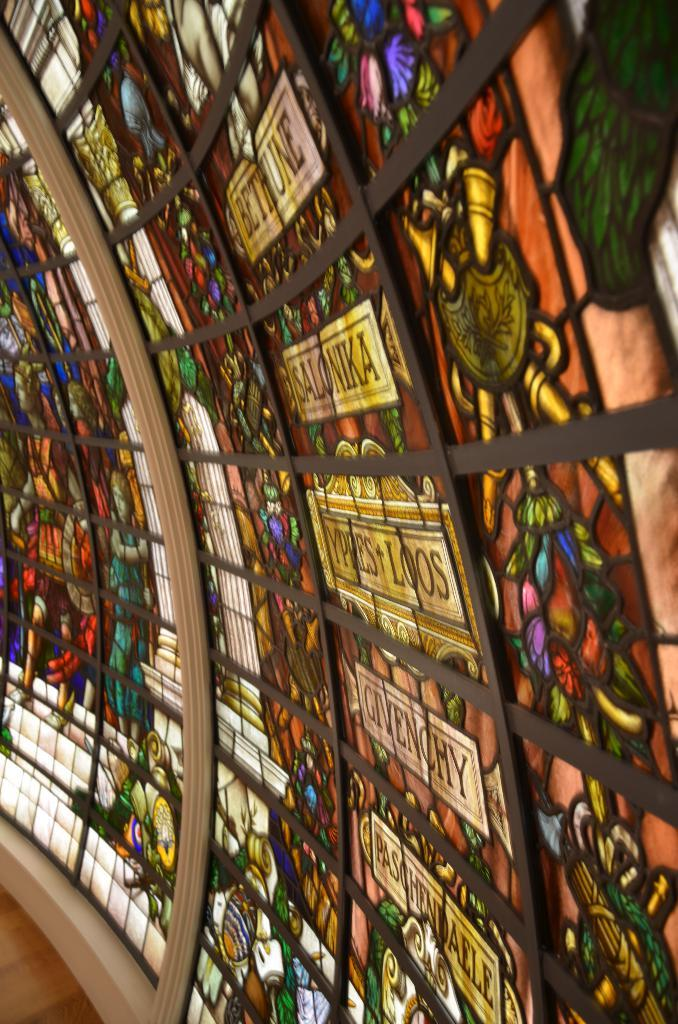What is on the windows in the image? There are paintings and decorations on the windows in the image. Can you describe the paintings on the windows? Unfortunately, the details of the paintings cannot be discerned from the image. What type of decorations are on the windows? The specific type of decorations cannot be determined from the image. How does the steam affect the paintings on the windows? There is no steam present in the image, so it cannot affect the paintings on the windows. 